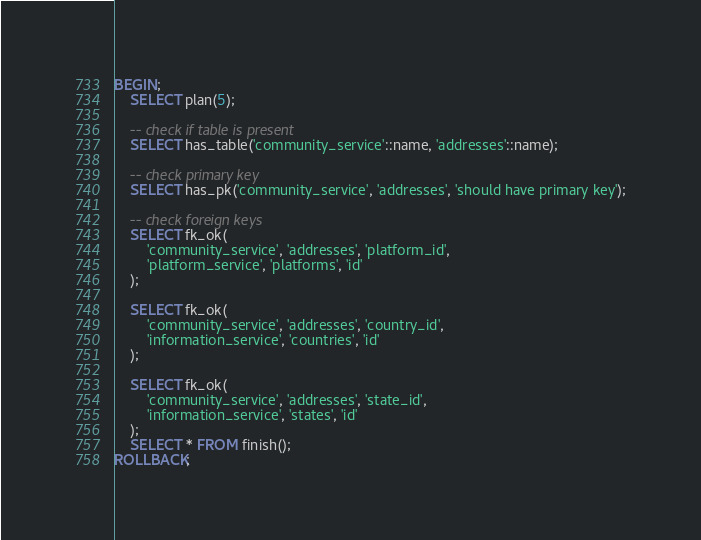<code> <loc_0><loc_0><loc_500><loc_500><_SQL_>BEGIN;
    SELECT plan(5);

    -- check if table is present
    SELECT has_table('community_service'::name, 'addresses'::name);

    -- check primary key
    SELECT has_pk('community_service', 'addresses', 'should have primary key');

    -- check foreign keys
    SELECT fk_ok(
        'community_service', 'addresses', 'platform_id',
        'platform_service', 'platforms', 'id'
    );

    SELECT fk_ok(
        'community_service', 'addresses', 'country_id',
        'information_service', 'countries', 'id'
    );

    SELECT fk_ok(
        'community_service', 'addresses', 'state_id',
        'information_service', 'states', 'id'
    );
    SELECT * FROM finish();
ROLLBACK;
</code> 